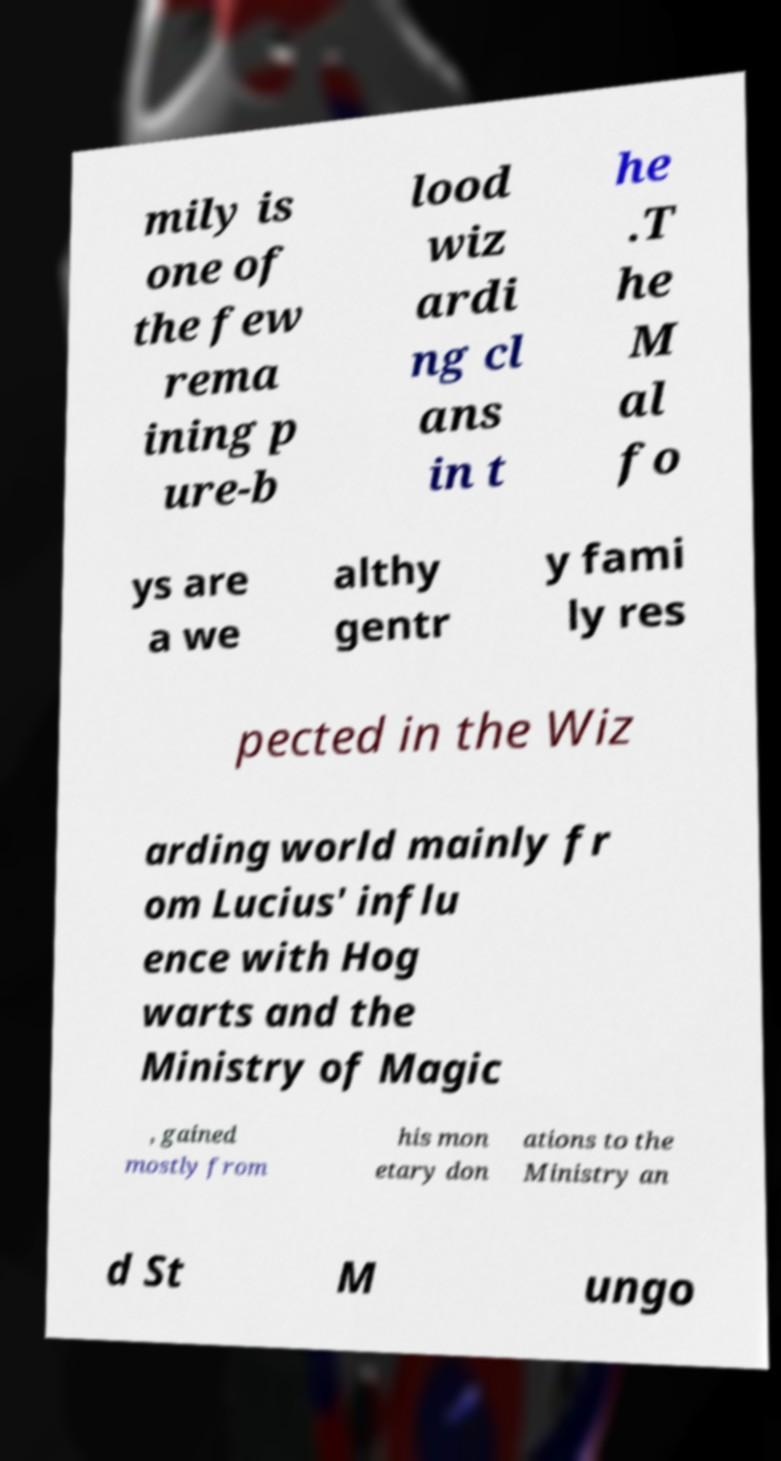Please read and relay the text visible in this image. What does it say? mily is one of the few rema ining p ure-b lood wiz ardi ng cl ans in t he .T he M al fo ys are a we althy gentr y fami ly res pected in the Wiz arding world mainly fr om Lucius' influ ence with Hog warts and the Ministry of Magic , gained mostly from his mon etary don ations to the Ministry an d St M ungo 